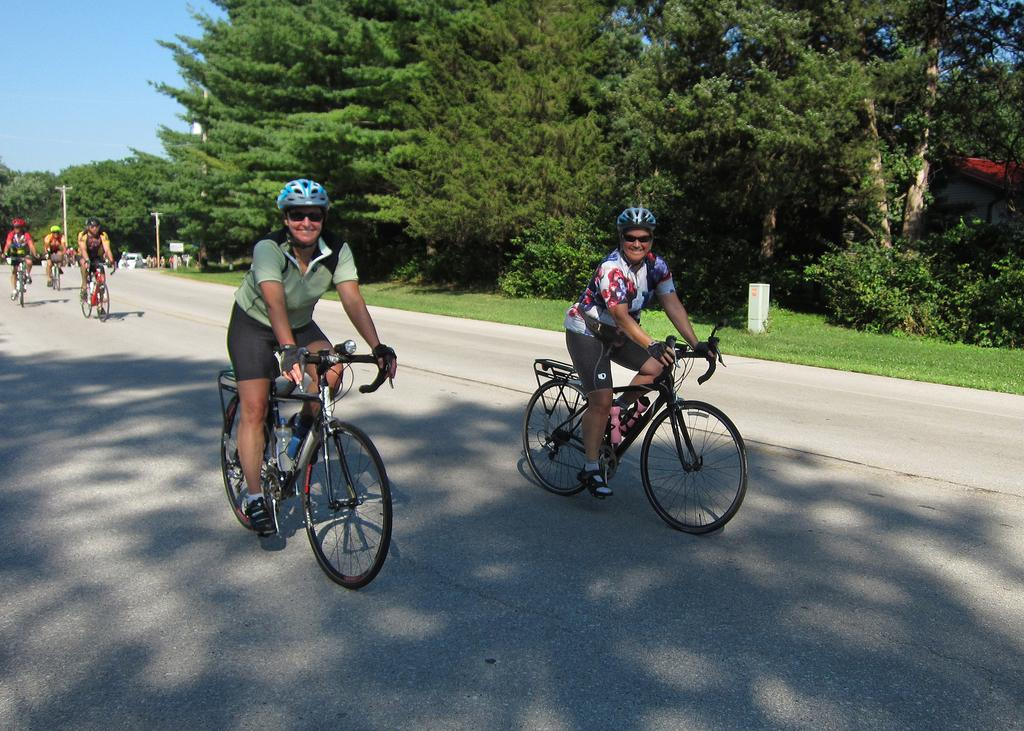What are the people in the image doing? People are cycling on the road in the image. What can be seen on the right side of the image? There is grass on the surface on the right side of the image. What is visible in the background of the image? There are trees and the sky visible in the background of the image. Can you see a whip being used by the cyclists in the image? No, there is no whip visible in the image. Are there any rats present in the image? No, there are no rats present in the image. 